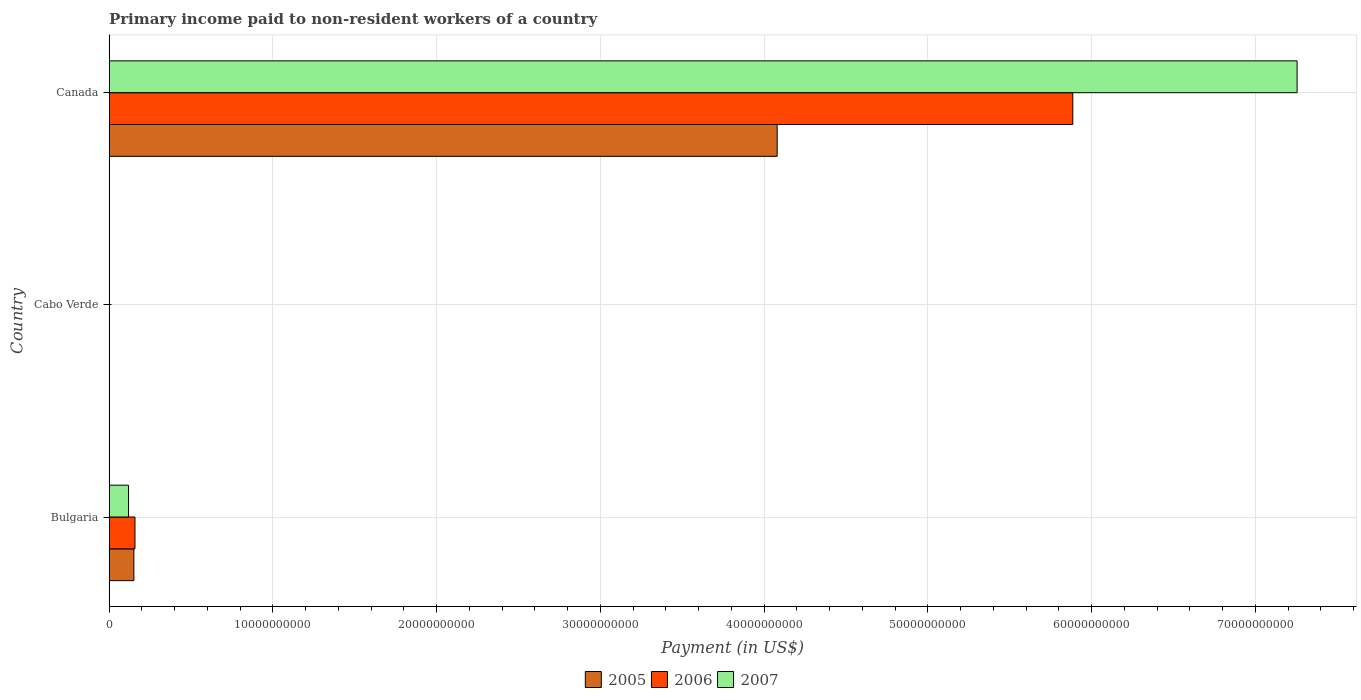What is the label of the 2nd group of bars from the top?
Your answer should be compact. Cabo Verde. What is the amount paid to workers in 2007 in Bulgaria?
Give a very brief answer. 1.19e+09. Across all countries, what is the maximum amount paid to workers in 2005?
Your answer should be very brief. 4.08e+1. Across all countries, what is the minimum amount paid to workers in 2007?
Ensure brevity in your answer.  2.67e+07. In which country was the amount paid to workers in 2007 minimum?
Provide a short and direct response. Cabo Verde. What is the total amount paid to workers in 2006 in the graph?
Keep it short and to the point. 6.05e+1. What is the difference between the amount paid to workers in 2006 in Cabo Verde and that in Canada?
Offer a very short reply. -5.88e+1. What is the difference between the amount paid to workers in 2006 in Cabo Verde and the amount paid to workers in 2005 in Bulgaria?
Ensure brevity in your answer.  -1.50e+09. What is the average amount paid to workers in 2005 per country?
Keep it short and to the point. 1.41e+1. What is the difference between the amount paid to workers in 2007 and amount paid to workers in 2005 in Bulgaria?
Offer a very short reply. -3.26e+08. What is the ratio of the amount paid to workers in 2007 in Bulgaria to that in Canada?
Make the answer very short. 0.02. What is the difference between the highest and the second highest amount paid to workers in 2005?
Provide a short and direct response. 3.93e+1. What is the difference between the highest and the lowest amount paid to workers in 2005?
Offer a very short reply. 4.08e+1. What does the 1st bar from the bottom in Cabo Verde represents?
Give a very brief answer. 2005. Are all the bars in the graph horizontal?
Your answer should be compact. Yes. Are the values on the major ticks of X-axis written in scientific E-notation?
Give a very brief answer. No. What is the title of the graph?
Give a very brief answer. Primary income paid to non-resident workers of a country. What is the label or title of the X-axis?
Provide a short and direct response. Payment (in US$). What is the label or title of the Y-axis?
Your response must be concise. Country. What is the Payment (in US$) of 2005 in Bulgaria?
Offer a terse response. 1.52e+09. What is the Payment (in US$) in 2006 in Bulgaria?
Keep it short and to the point. 1.58e+09. What is the Payment (in US$) in 2007 in Bulgaria?
Your answer should be compact. 1.19e+09. What is the Payment (in US$) in 2005 in Cabo Verde?
Give a very brief answer. 1.92e+07. What is the Payment (in US$) of 2006 in Cabo Verde?
Make the answer very short. 1.91e+07. What is the Payment (in US$) of 2007 in Cabo Verde?
Provide a succinct answer. 2.67e+07. What is the Payment (in US$) in 2005 in Canada?
Provide a succinct answer. 4.08e+1. What is the Payment (in US$) of 2006 in Canada?
Ensure brevity in your answer.  5.89e+1. What is the Payment (in US$) in 2007 in Canada?
Make the answer very short. 7.26e+1. Across all countries, what is the maximum Payment (in US$) in 2005?
Your answer should be very brief. 4.08e+1. Across all countries, what is the maximum Payment (in US$) in 2006?
Your answer should be compact. 5.89e+1. Across all countries, what is the maximum Payment (in US$) in 2007?
Give a very brief answer. 7.26e+1. Across all countries, what is the minimum Payment (in US$) in 2005?
Ensure brevity in your answer.  1.92e+07. Across all countries, what is the minimum Payment (in US$) of 2006?
Offer a terse response. 1.91e+07. Across all countries, what is the minimum Payment (in US$) in 2007?
Your response must be concise. 2.67e+07. What is the total Payment (in US$) in 2005 in the graph?
Your answer should be compact. 4.23e+1. What is the total Payment (in US$) of 2006 in the graph?
Ensure brevity in your answer.  6.05e+1. What is the total Payment (in US$) in 2007 in the graph?
Provide a succinct answer. 7.38e+1. What is the difference between the Payment (in US$) of 2005 in Bulgaria and that in Cabo Verde?
Keep it short and to the point. 1.50e+09. What is the difference between the Payment (in US$) of 2006 in Bulgaria and that in Cabo Verde?
Provide a short and direct response. 1.56e+09. What is the difference between the Payment (in US$) of 2007 in Bulgaria and that in Cabo Verde?
Make the answer very short. 1.16e+09. What is the difference between the Payment (in US$) in 2005 in Bulgaria and that in Canada?
Your response must be concise. -3.93e+1. What is the difference between the Payment (in US$) of 2006 in Bulgaria and that in Canada?
Your response must be concise. -5.73e+1. What is the difference between the Payment (in US$) of 2007 in Bulgaria and that in Canada?
Provide a succinct answer. -7.14e+1. What is the difference between the Payment (in US$) in 2005 in Cabo Verde and that in Canada?
Your response must be concise. -4.08e+1. What is the difference between the Payment (in US$) of 2006 in Cabo Verde and that in Canada?
Provide a succinct answer. -5.88e+1. What is the difference between the Payment (in US$) in 2007 in Cabo Verde and that in Canada?
Ensure brevity in your answer.  -7.25e+1. What is the difference between the Payment (in US$) in 2005 in Bulgaria and the Payment (in US$) in 2006 in Cabo Verde?
Offer a very short reply. 1.50e+09. What is the difference between the Payment (in US$) of 2005 in Bulgaria and the Payment (in US$) of 2007 in Cabo Verde?
Your answer should be very brief. 1.49e+09. What is the difference between the Payment (in US$) in 2006 in Bulgaria and the Payment (in US$) in 2007 in Cabo Verde?
Give a very brief answer. 1.55e+09. What is the difference between the Payment (in US$) in 2005 in Bulgaria and the Payment (in US$) in 2006 in Canada?
Ensure brevity in your answer.  -5.73e+1. What is the difference between the Payment (in US$) of 2005 in Bulgaria and the Payment (in US$) of 2007 in Canada?
Give a very brief answer. -7.10e+1. What is the difference between the Payment (in US$) in 2006 in Bulgaria and the Payment (in US$) in 2007 in Canada?
Make the answer very short. -7.10e+1. What is the difference between the Payment (in US$) in 2005 in Cabo Verde and the Payment (in US$) in 2006 in Canada?
Ensure brevity in your answer.  -5.88e+1. What is the difference between the Payment (in US$) of 2005 in Cabo Verde and the Payment (in US$) of 2007 in Canada?
Provide a succinct answer. -7.25e+1. What is the difference between the Payment (in US$) of 2006 in Cabo Verde and the Payment (in US$) of 2007 in Canada?
Offer a terse response. -7.25e+1. What is the average Payment (in US$) in 2005 per country?
Your response must be concise. 1.41e+1. What is the average Payment (in US$) of 2006 per country?
Offer a very short reply. 2.02e+1. What is the average Payment (in US$) of 2007 per country?
Your answer should be compact. 2.46e+1. What is the difference between the Payment (in US$) in 2005 and Payment (in US$) in 2006 in Bulgaria?
Offer a terse response. -6.60e+07. What is the difference between the Payment (in US$) in 2005 and Payment (in US$) in 2007 in Bulgaria?
Provide a short and direct response. 3.26e+08. What is the difference between the Payment (in US$) in 2006 and Payment (in US$) in 2007 in Bulgaria?
Your answer should be very brief. 3.92e+08. What is the difference between the Payment (in US$) of 2005 and Payment (in US$) of 2006 in Cabo Verde?
Your answer should be compact. 1.54e+05. What is the difference between the Payment (in US$) of 2005 and Payment (in US$) of 2007 in Cabo Verde?
Make the answer very short. -7.50e+06. What is the difference between the Payment (in US$) of 2006 and Payment (in US$) of 2007 in Cabo Verde?
Ensure brevity in your answer.  -7.66e+06. What is the difference between the Payment (in US$) of 2005 and Payment (in US$) of 2006 in Canada?
Give a very brief answer. -1.81e+1. What is the difference between the Payment (in US$) of 2005 and Payment (in US$) of 2007 in Canada?
Your response must be concise. -3.18e+1. What is the difference between the Payment (in US$) of 2006 and Payment (in US$) of 2007 in Canada?
Make the answer very short. -1.37e+1. What is the ratio of the Payment (in US$) of 2005 in Bulgaria to that in Cabo Verde?
Your answer should be very brief. 78.83. What is the ratio of the Payment (in US$) of 2006 in Bulgaria to that in Cabo Verde?
Your answer should be very brief. 82.93. What is the ratio of the Payment (in US$) in 2007 in Bulgaria to that in Cabo Verde?
Your answer should be very brief. 44.5. What is the ratio of the Payment (in US$) in 2005 in Bulgaria to that in Canada?
Provide a succinct answer. 0.04. What is the ratio of the Payment (in US$) in 2006 in Bulgaria to that in Canada?
Make the answer very short. 0.03. What is the ratio of the Payment (in US$) of 2007 in Bulgaria to that in Canada?
Your answer should be very brief. 0.02. What is the ratio of the Payment (in US$) of 2007 in Cabo Verde to that in Canada?
Make the answer very short. 0. What is the difference between the highest and the second highest Payment (in US$) of 2005?
Make the answer very short. 3.93e+1. What is the difference between the highest and the second highest Payment (in US$) of 2006?
Offer a terse response. 5.73e+1. What is the difference between the highest and the second highest Payment (in US$) in 2007?
Provide a short and direct response. 7.14e+1. What is the difference between the highest and the lowest Payment (in US$) in 2005?
Offer a very short reply. 4.08e+1. What is the difference between the highest and the lowest Payment (in US$) of 2006?
Ensure brevity in your answer.  5.88e+1. What is the difference between the highest and the lowest Payment (in US$) in 2007?
Make the answer very short. 7.25e+1. 